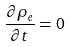<formula> <loc_0><loc_0><loc_500><loc_500>\frac { \partial \rho _ { e } } { \partial t } = 0</formula> 